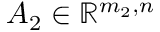<formula> <loc_0><loc_0><loc_500><loc_500>A _ { 2 } \in \mathbb { R } ^ { m _ { 2 } , n }</formula> 